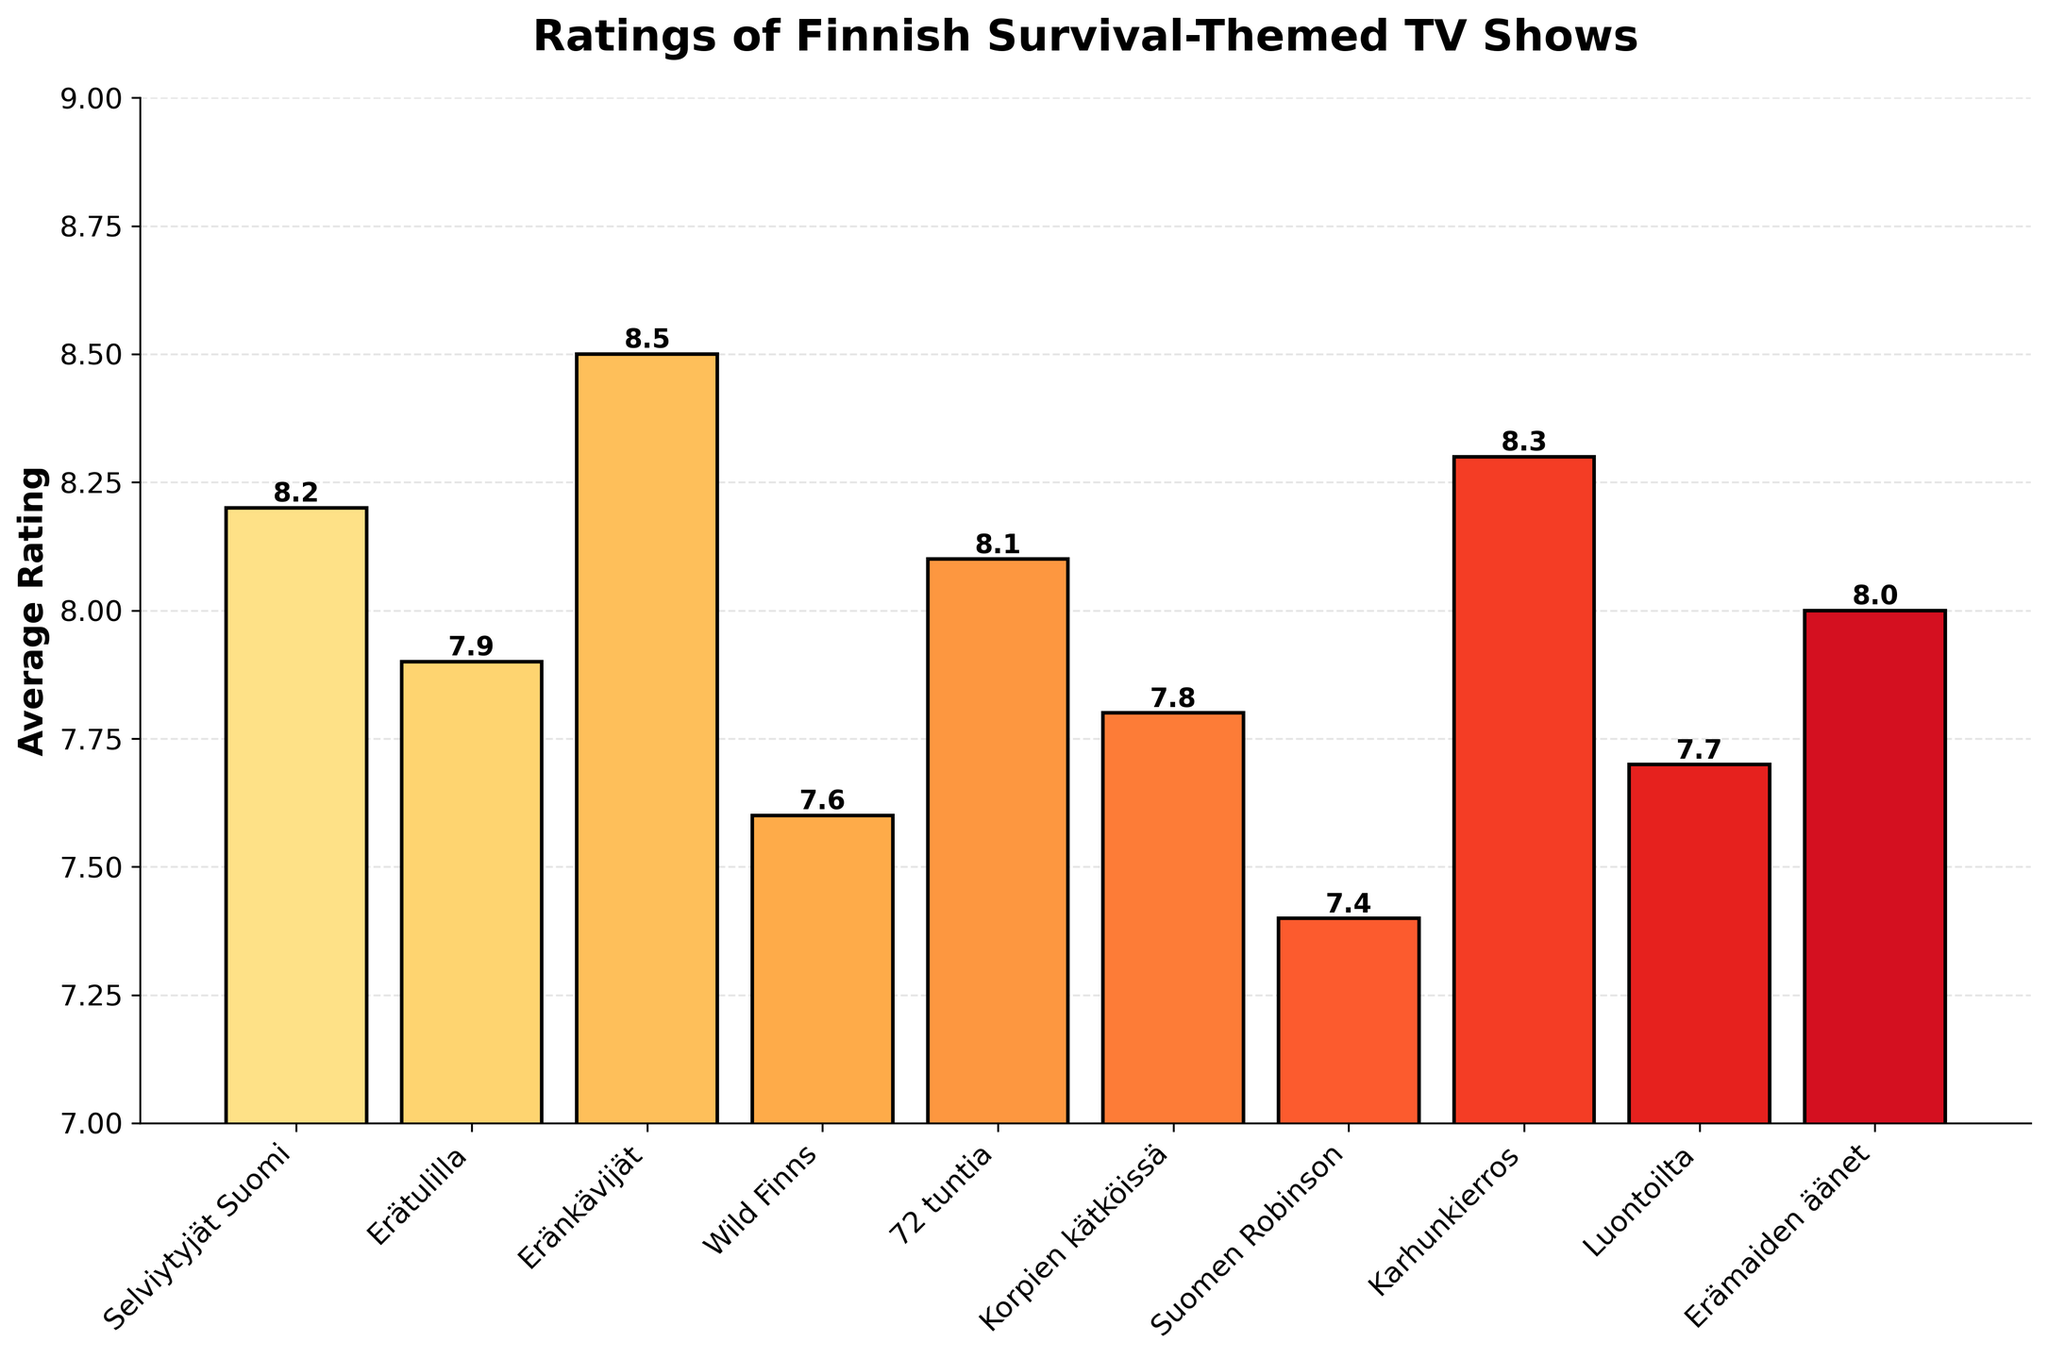Which show has the highest average rating? By looking at the heights of the bars, "Eränkävijät" has the tallest bar, indicating it has the highest average rating.
Answer: Eränkävijät Which two shows have the closest average ratings? Looking at the bar heights, "Korpien kätköissä" and "Luontoilta" have the closest average ratings, both around 7.8 and 7.7 respectively.
Answer: Korpien kätköissä and Luontoilta How much higher is the average rating of "Karhunkierros" compared to "Wild Finns"? "Karhunkierros" has an average rating of 8.3, and "Wild Finns" has a rating of 7.6. The difference is 8.3 - 7.6 = 0.7.
Answer: 0.7 Which show has an average rating higher than "Selviytyjät Suomi" but less than "Karhunkierros"? "Selviytyjät Suomi" has an average rating of 8.2 and "Karhunkierros" has 8.3. "72 tuntia" fits between these values with a rating of 8.1.
Answer: 72 tuntia What is the combined average rating of "Erätulilla" and "Erämaiden äänet"? "Erätulilla" has an average rating of 7.9 and "Erämaiden äänet" has 8.0. Their combined rating is 7.9 + 8.0 = 15.9.
Answer: 15.9 Which shows have an average rating below 8.0? Shows with bars below the 8.0 horizontal line are "Wild Finns" (7.6), "Korpien kätköissä" (7.8), "Luontoilta" (7.7), and "Suomen Robinson" (7.4).
Answer: Wild Finns, Korpien kätköissä, Luontoilta, Suomen Robinson Which show has a visually darker shade among "Selviytyjät Suomi" and "72 tuntia"? The bar color representing "Selviytyjät Suomi" and "72 tuntia" is a gradient of yellow-orange-red. Comparing the shades, "Selviytyjät Suomi" shows a lighter shade due to its lesser average rating compared to "72 tuntia".
Answer: 72 tuntia 